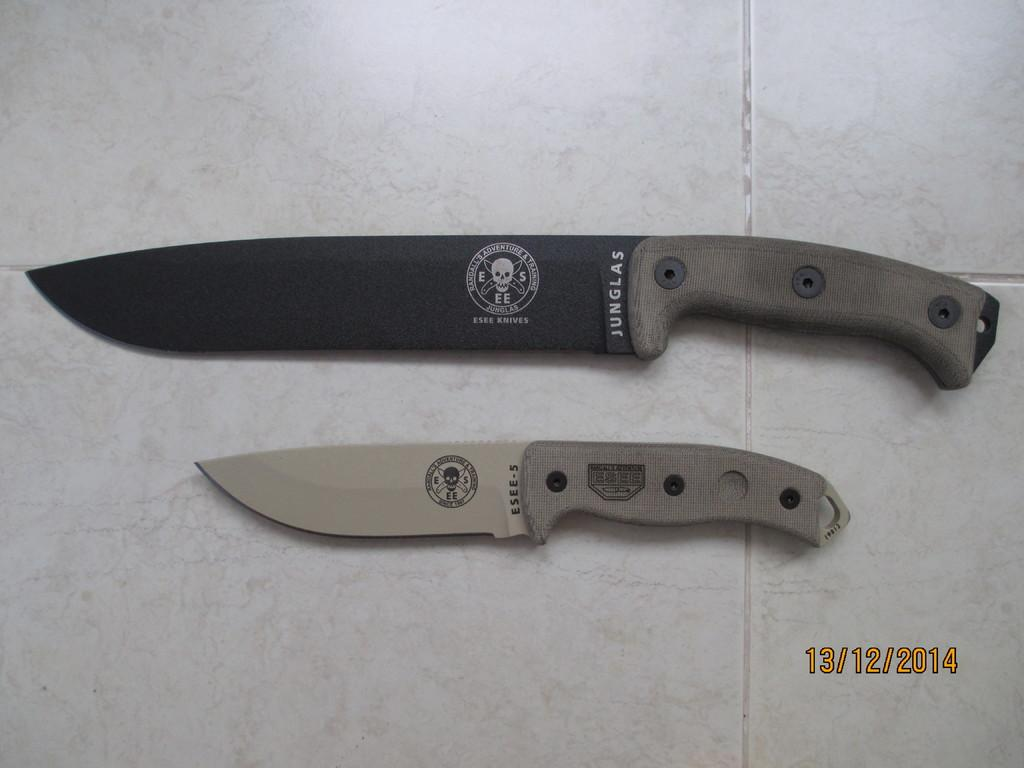<image>
Give a short and clear explanation of the subsequent image. Two examples of Esee knives lay size by side, one bigger than the other. 